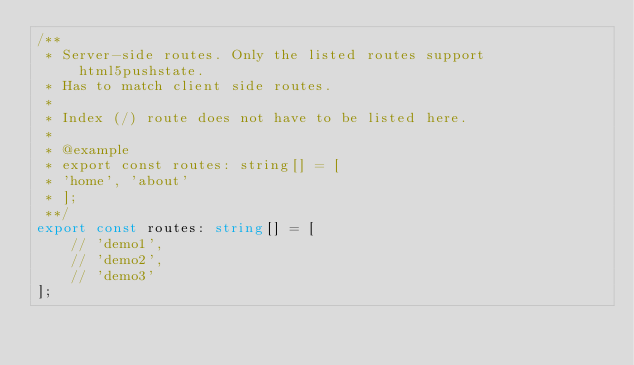<code> <loc_0><loc_0><loc_500><loc_500><_TypeScript_>/**
 * Server-side routes. Only the listed routes support html5pushstate.
 * Has to match client side routes.
 *
 * Index (/) route does not have to be listed here.
 *
 * @example
 * export const routes: string[] = [
 * 'home', 'about'
 * ];
 **/
export const routes: string[] = [
    // 'demo1',
    // 'demo2',
    // 'demo3'
];
</code> 